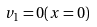Convert formula to latex. <formula><loc_0><loc_0><loc_500><loc_500>v _ { 1 } = 0 ( x = 0 )</formula> 